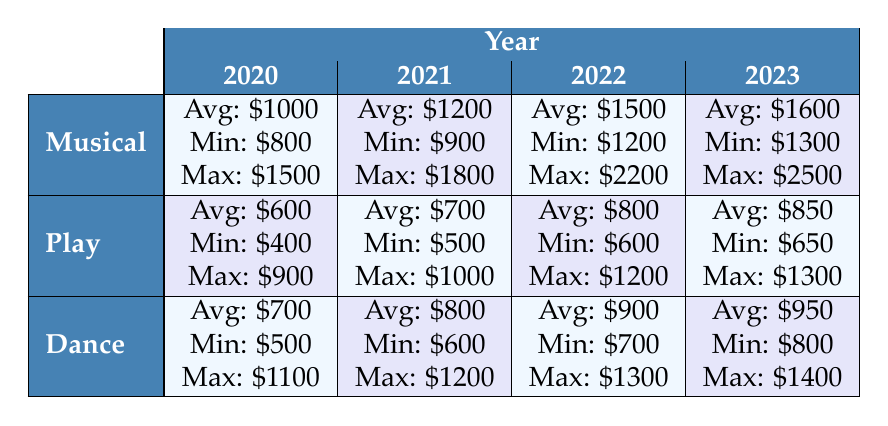What is the average rental cost for a musical in 2021? The average rental cost for a musical in 2021 is listed in the table as $1200.
Answer: 1200 What year had the highest minimum rental cost for plays? In the table, the minimum rental costs for plays are $400 in 2020, $500 in 2021, $600 in 2022, and $650 in 2023. The highest minimum cost is $650 in 2023.
Answer: 2023 What is the total average rental cost for all production types in 2022? The average rental costs for all production types in 2022 are $1500 (musical) + $800 (play) + $900 (dance) = $3200. There are three production types, so the total average is $3200.
Answer: 3200 Is the maximum rental cost for dance higher in 2022 than in 2021? The maximum rental costs for dance are $1200 in 2021 and $1300 in 2022. Since $1300 (2022) is greater than $1200 (2021), the statement is true.
Answer: Yes What is the difference in average rental costs between musicals and plays in 2020? In 2020, the average rental cost for musicals is $1000 and for plays is $600. The difference is $1000 - $600 = $400.
Answer: 400 What is the average increase in average rental costs for musicals from 2020 to 2023? The average rental costs for musicals are $1000 in 2020 and $1600 in 2023. The increase is $1600 - $1000 = $600. The average increase over the three years (2020 to 2023) is $600 divided by the number of years, which is 3. The average annual increase is $200 per year.
Answer: 200 Is the average rental cost for dance in 2023 the highest compared to the previous years? The average rental cost for dance over the years is $700 in 2020, $800 in 2021, $900 in 2022, and $950 in 2023. Since $950 is greater than the previous years, the answer is true.
Answer: Yes What is the maximum rental cost for a play in 2022? The maximum rental cost for a play in 2022 is listed in the table as $1200.
Answer: 1200 